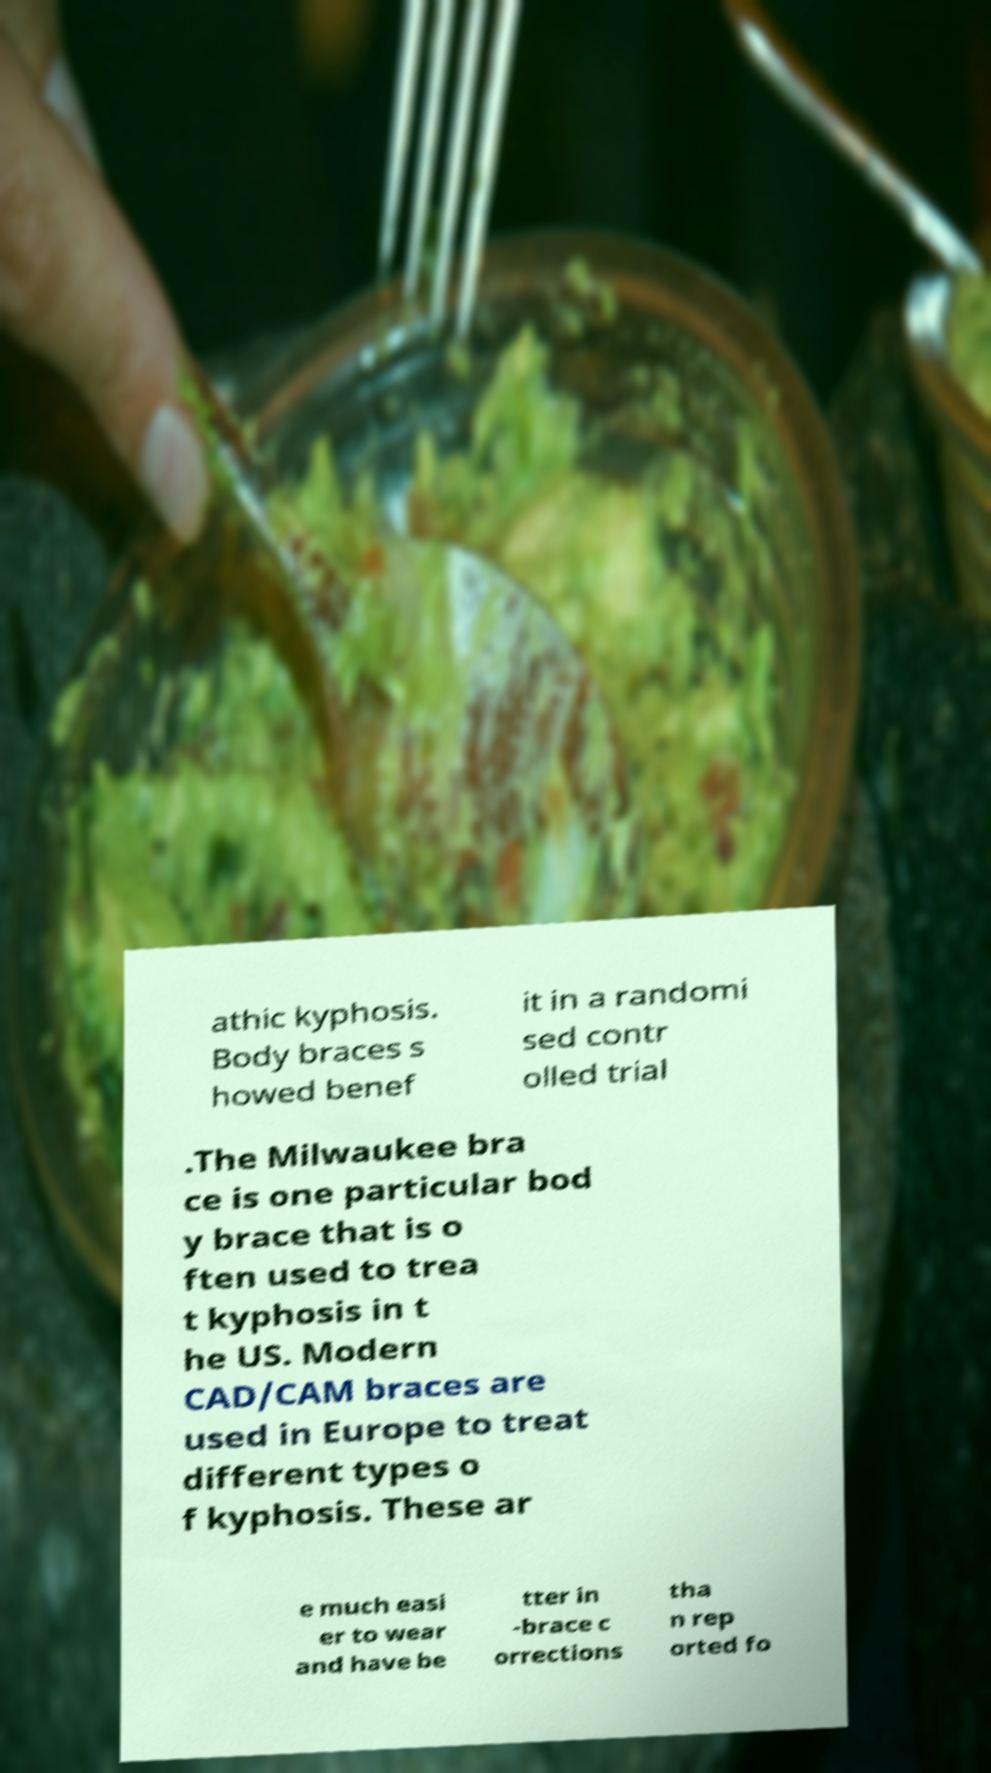What messages or text are displayed in this image? I need them in a readable, typed format. athic kyphosis. Body braces s howed benef it in a randomi sed contr olled trial .The Milwaukee bra ce is one particular bod y brace that is o ften used to trea t kyphosis in t he US. Modern CAD/CAM braces are used in Europe to treat different types o f kyphosis. These ar e much easi er to wear and have be tter in -brace c orrections tha n rep orted fo 